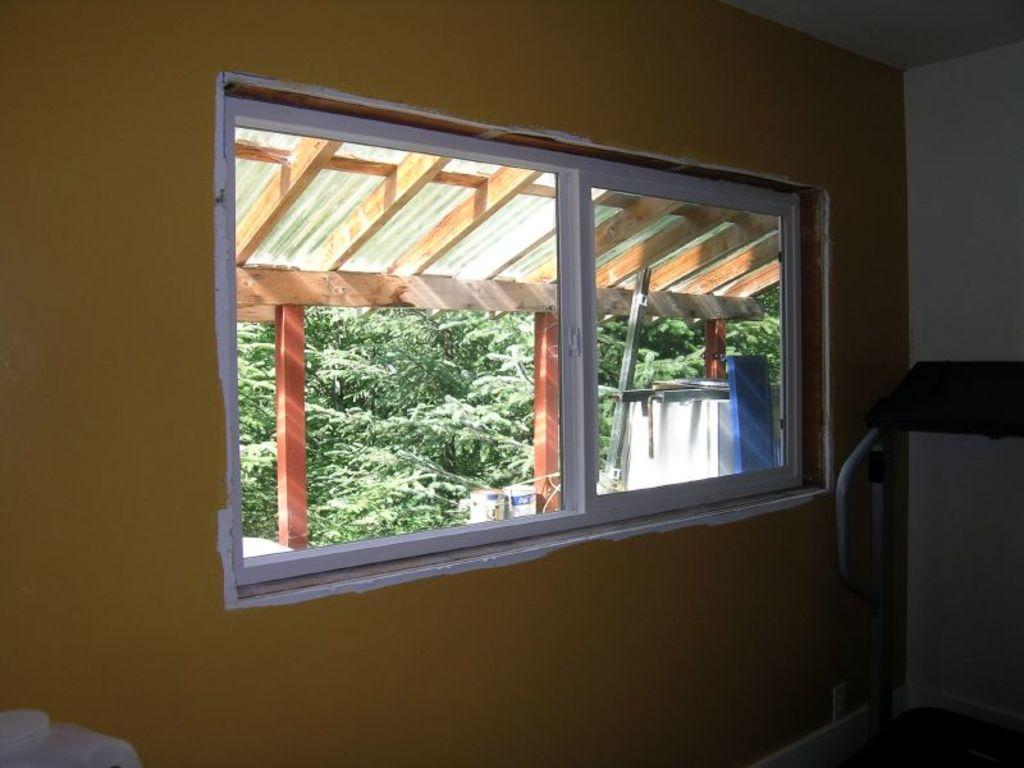What type of structure can be seen in the image? There is a wall with a window in the image. What else is present in the image besides the wall and window? There are objects and pillars in the image. What can be seen in the background of the image? There are trees in the background of the image. Can you tell me how many ghosts are visible through the window in the image? There are no ghosts visible through the window in the image. What type of edge can be seen on the objects in the image? The provided facts do not mention any specific edges on the objects in the image. 